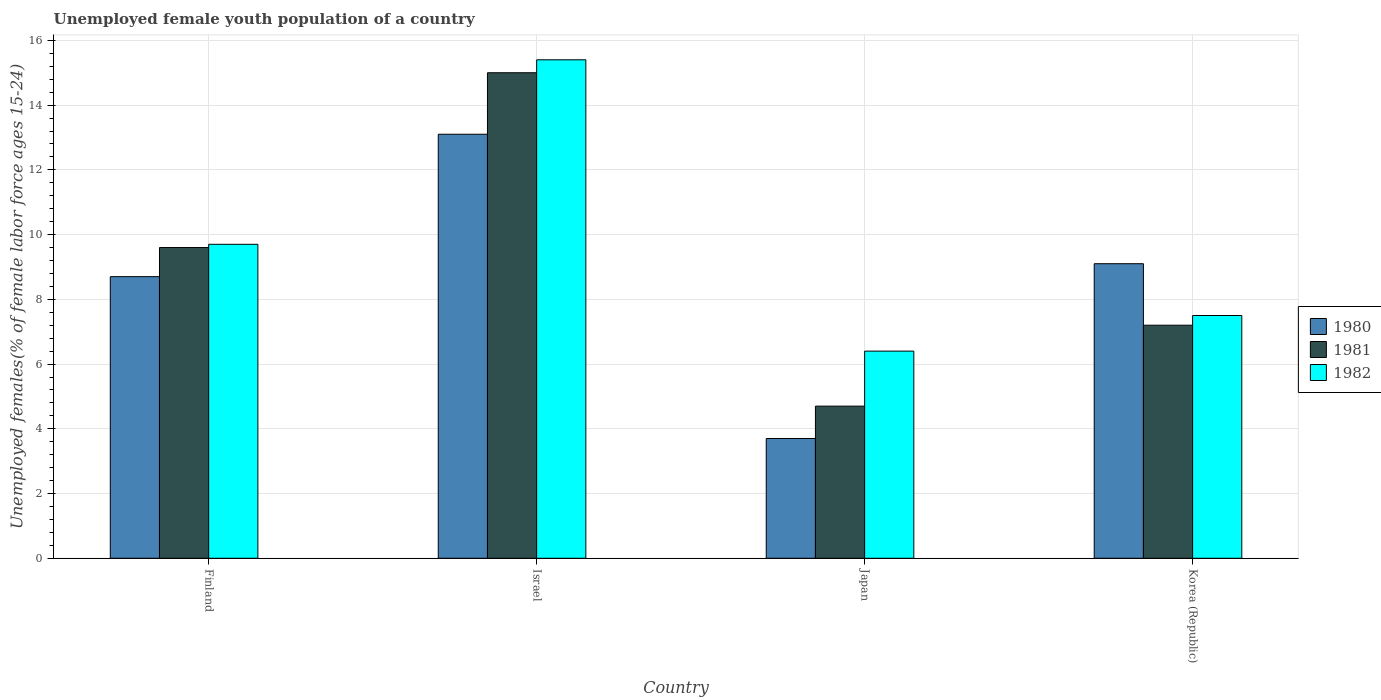How many groups of bars are there?
Keep it short and to the point. 4. Are the number of bars per tick equal to the number of legend labels?
Make the answer very short. Yes. How many bars are there on the 1st tick from the right?
Offer a terse response. 3. What is the label of the 2nd group of bars from the left?
Provide a succinct answer. Israel. What is the percentage of unemployed female youth population in 1980 in Korea (Republic)?
Ensure brevity in your answer.  9.1. Across all countries, what is the maximum percentage of unemployed female youth population in 1982?
Provide a short and direct response. 15.4. Across all countries, what is the minimum percentage of unemployed female youth population in 1980?
Your response must be concise. 3.7. What is the total percentage of unemployed female youth population in 1980 in the graph?
Offer a terse response. 34.6. What is the difference between the percentage of unemployed female youth population in 1981 in Israel and that in Korea (Republic)?
Keep it short and to the point. 7.8. What is the difference between the percentage of unemployed female youth population in 1982 in Korea (Republic) and the percentage of unemployed female youth population in 1980 in Israel?
Provide a succinct answer. -5.6. What is the average percentage of unemployed female youth population in 1980 per country?
Provide a succinct answer. 8.65. What is the difference between the percentage of unemployed female youth population of/in 1980 and percentage of unemployed female youth population of/in 1981 in Japan?
Make the answer very short. -1. In how many countries, is the percentage of unemployed female youth population in 1980 greater than 8.4 %?
Your answer should be compact. 3. What is the ratio of the percentage of unemployed female youth population in 1980 in Israel to that in Korea (Republic)?
Give a very brief answer. 1.44. Is the percentage of unemployed female youth population in 1981 in Finland less than that in Korea (Republic)?
Make the answer very short. No. What is the difference between the highest and the second highest percentage of unemployed female youth population in 1981?
Your response must be concise. 2.4. What is the difference between the highest and the lowest percentage of unemployed female youth population in 1981?
Give a very brief answer. 10.3. Is the sum of the percentage of unemployed female youth population in 1982 in Finland and Israel greater than the maximum percentage of unemployed female youth population in 1980 across all countries?
Offer a very short reply. Yes. What does the 2nd bar from the left in Korea (Republic) represents?
Provide a short and direct response. 1981. What does the 3rd bar from the right in Finland represents?
Offer a terse response. 1980. How many countries are there in the graph?
Give a very brief answer. 4. Does the graph contain grids?
Your response must be concise. Yes. How many legend labels are there?
Keep it short and to the point. 3. How are the legend labels stacked?
Your answer should be very brief. Vertical. What is the title of the graph?
Give a very brief answer. Unemployed female youth population of a country. What is the label or title of the X-axis?
Give a very brief answer. Country. What is the label or title of the Y-axis?
Provide a succinct answer. Unemployed females(% of female labor force ages 15-24). What is the Unemployed females(% of female labor force ages 15-24) in 1980 in Finland?
Your answer should be compact. 8.7. What is the Unemployed females(% of female labor force ages 15-24) in 1981 in Finland?
Keep it short and to the point. 9.6. What is the Unemployed females(% of female labor force ages 15-24) in 1982 in Finland?
Your response must be concise. 9.7. What is the Unemployed females(% of female labor force ages 15-24) of 1980 in Israel?
Keep it short and to the point. 13.1. What is the Unemployed females(% of female labor force ages 15-24) in 1982 in Israel?
Give a very brief answer. 15.4. What is the Unemployed females(% of female labor force ages 15-24) in 1980 in Japan?
Your answer should be compact. 3.7. What is the Unemployed females(% of female labor force ages 15-24) in 1981 in Japan?
Your response must be concise. 4.7. What is the Unemployed females(% of female labor force ages 15-24) in 1982 in Japan?
Your answer should be compact. 6.4. What is the Unemployed females(% of female labor force ages 15-24) in 1980 in Korea (Republic)?
Offer a very short reply. 9.1. What is the Unemployed females(% of female labor force ages 15-24) in 1981 in Korea (Republic)?
Make the answer very short. 7.2. What is the Unemployed females(% of female labor force ages 15-24) in 1982 in Korea (Republic)?
Ensure brevity in your answer.  7.5. Across all countries, what is the maximum Unemployed females(% of female labor force ages 15-24) in 1980?
Make the answer very short. 13.1. Across all countries, what is the maximum Unemployed females(% of female labor force ages 15-24) of 1981?
Your answer should be compact. 15. Across all countries, what is the maximum Unemployed females(% of female labor force ages 15-24) of 1982?
Your answer should be very brief. 15.4. Across all countries, what is the minimum Unemployed females(% of female labor force ages 15-24) of 1980?
Offer a terse response. 3.7. Across all countries, what is the minimum Unemployed females(% of female labor force ages 15-24) of 1981?
Give a very brief answer. 4.7. Across all countries, what is the minimum Unemployed females(% of female labor force ages 15-24) in 1982?
Keep it short and to the point. 6.4. What is the total Unemployed females(% of female labor force ages 15-24) in 1980 in the graph?
Provide a short and direct response. 34.6. What is the total Unemployed females(% of female labor force ages 15-24) in 1981 in the graph?
Your answer should be compact. 36.5. What is the difference between the Unemployed females(% of female labor force ages 15-24) in 1980 in Finland and that in Israel?
Your answer should be very brief. -4.4. What is the difference between the Unemployed females(% of female labor force ages 15-24) in 1982 in Finland and that in Israel?
Your answer should be compact. -5.7. What is the difference between the Unemployed females(% of female labor force ages 15-24) in 1982 in Finland and that in Japan?
Give a very brief answer. 3.3. What is the difference between the Unemployed females(% of female labor force ages 15-24) of 1981 in Finland and that in Korea (Republic)?
Keep it short and to the point. 2.4. What is the difference between the Unemployed females(% of female labor force ages 15-24) of 1980 in Israel and that in Japan?
Provide a succinct answer. 9.4. What is the difference between the Unemployed females(% of female labor force ages 15-24) in 1982 in Israel and that in Japan?
Offer a very short reply. 9. What is the difference between the Unemployed females(% of female labor force ages 15-24) in 1981 in Israel and that in Korea (Republic)?
Provide a succinct answer. 7.8. What is the difference between the Unemployed females(% of female labor force ages 15-24) in 1981 in Japan and that in Korea (Republic)?
Offer a terse response. -2.5. What is the difference between the Unemployed females(% of female labor force ages 15-24) in 1980 in Finland and the Unemployed females(% of female labor force ages 15-24) in 1981 in Israel?
Make the answer very short. -6.3. What is the difference between the Unemployed females(% of female labor force ages 15-24) of 1981 in Finland and the Unemployed females(% of female labor force ages 15-24) of 1982 in Israel?
Make the answer very short. -5.8. What is the difference between the Unemployed females(% of female labor force ages 15-24) of 1980 in Finland and the Unemployed females(% of female labor force ages 15-24) of 1981 in Japan?
Your response must be concise. 4. What is the difference between the Unemployed females(% of female labor force ages 15-24) of 1980 in Finland and the Unemployed females(% of female labor force ages 15-24) of 1982 in Japan?
Offer a terse response. 2.3. What is the difference between the Unemployed females(% of female labor force ages 15-24) of 1980 in Finland and the Unemployed females(% of female labor force ages 15-24) of 1981 in Korea (Republic)?
Make the answer very short. 1.5. What is the difference between the Unemployed females(% of female labor force ages 15-24) in 1980 in Finland and the Unemployed females(% of female labor force ages 15-24) in 1982 in Korea (Republic)?
Your answer should be very brief. 1.2. What is the difference between the Unemployed females(% of female labor force ages 15-24) in 1980 in Israel and the Unemployed females(% of female labor force ages 15-24) in 1981 in Japan?
Your response must be concise. 8.4. What is the difference between the Unemployed females(% of female labor force ages 15-24) in 1980 in Israel and the Unemployed females(% of female labor force ages 15-24) in 1982 in Japan?
Offer a terse response. 6.7. What is the difference between the Unemployed females(% of female labor force ages 15-24) of 1980 in Israel and the Unemployed females(% of female labor force ages 15-24) of 1981 in Korea (Republic)?
Your answer should be compact. 5.9. What is the difference between the Unemployed females(% of female labor force ages 15-24) in 1981 in Israel and the Unemployed females(% of female labor force ages 15-24) in 1982 in Korea (Republic)?
Your response must be concise. 7.5. What is the difference between the Unemployed females(% of female labor force ages 15-24) of 1980 in Japan and the Unemployed females(% of female labor force ages 15-24) of 1981 in Korea (Republic)?
Ensure brevity in your answer.  -3.5. What is the difference between the Unemployed females(% of female labor force ages 15-24) in 1980 in Japan and the Unemployed females(% of female labor force ages 15-24) in 1982 in Korea (Republic)?
Your answer should be very brief. -3.8. What is the average Unemployed females(% of female labor force ages 15-24) of 1980 per country?
Give a very brief answer. 8.65. What is the average Unemployed females(% of female labor force ages 15-24) of 1981 per country?
Ensure brevity in your answer.  9.12. What is the average Unemployed females(% of female labor force ages 15-24) of 1982 per country?
Make the answer very short. 9.75. What is the difference between the Unemployed females(% of female labor force ages 15-24) in 1980 and Unemployed females(% of female labor force ages 15-24) in 1981 in Finland?
Your answer should be very brief. -0.9. What is the difference between the Unemployed females(% of female labor force ages 15-24) of 1980 and Unemployed females(% of female labor force ages 15-24) of 1982 in Finland?
Your answer should be compact. -1. What is the difference between the Unemployed females(% of female labor force ages 15-24) of 1981 and Unemployed females(% of female labor force ages 15-24) of 1982 in Finland?
Provide a succinct answer. -0.1. What is the difference between the Unemployed females(% of female labor force ages 15-24) in 1980 and Unemployed females(% of female labor force ages 15-24) in 1982 in Israel?
Provide a succinct answer. -2.3. What is the difference between the Unemployed females(% of female labor force ages 15-24) in 1980 and Unemployed females(% of female labor force ages 15-24) in 1981 in Japan?
Ensure brevity in your answer.  -1. What is the difference between the Unemployed females(% of female labor force ages 15-24) in 1980 and Unemployed females(% of female labor force ages 15-24) in 1982 in Japan?
Provide a short and direct response. -2.7. What is the difference between the Unemployed females(% of female labor force ages 15-24) of 1981 and Unemployed females(% of female labor force ages 15-24) of 1982 in Japan?
Your answer should be compact. -1.7. What is the difference between the Unemployed females(% of female labor force ages 15-24) in 1980 and Unemployed females(% of female labor force ages 15-24) in 1982 in Korea (Republic)?
Provide a short and direct response. 1.6. What is the ratio of the Unemployed females(% of female labor force ages 15-24) of 1980 in Finland to that in Israel?
Make the answer very short. 0.66. What is the ratio of the Unemployed females(% of female labor force ages 15-24) of 1981 in Finland to that in Israel?
Give a very brief answer. 0.64. What is the ratio of the Unemployed females(% of female labor force ages 15-24) in 1982 in Finland to that in Israel?
Your response must be concise. 0.63. What is the ratio of the Unemployed females(% of female labor force ages 15-24) in 1980 in Finland to that in Japan?
Your answer should be compact. 2.35. What is the ratio of the Unemployed females(% of female labor force ages 15-24) of 1981 in Finland to that in Japan?
Your answer should be compact. 2.04. What is the ratio of the Unemployed females(% of female labor force ages 15-24) in 1982 in Finland to that in Japan?
Make the answer very short. 1.52. What is the ratio of the Unemployed females(% of female labor force ages 15-24) in 1980 in Finland to that in Korea (Republic)?
Provide a short and direct response. 0.96. What is the ratio of the Unemployed females(% of female labor force ages 15-24) in 1981 in Finland to that in Korea (Republic)?
Make the answer very short. 1.33. What is the ratio of the Unemployed females(% of female labor force ages 15-24) in 1982 in Finland to that in Korea (Republic)?
Your answer should be very brief. 1.29. What is the ratio of the Unemployed females(% of female labor force ages 15-24) in 1980 in Israel to that in Japan?
Provide a succinct answer. 3.54. What is the ratio of the Unemployed females(% of female labor force ages 15-24) in 1981 in Israel to that in Japan?
Provide a short and direct response. 3.19. What is the ratio of the Unemployed females(% of female labor force ages 15-24) in 1982 in Israel to that in Japan?
Your response must be concise. 2.41. What is the ratio of the Unemployed females(% of female labor force ages 15-24) of 1980 in Israel to that in Korea (Republic)?
Ensure brevity in your answer.  1.44. What is the ratio of the Unemployed females(% of female labor force ages 15-24) in 1981 in Israel to that in Korea (Republic)?
Provide a short and direct response. 2.08. What is the ratio of the Unemployed females(% of female labor force ages 15-24) of 1982 in Israel to that in Korea (Republic)?
Your answer should be very brief. 2.05. What is the ratio of the Unemployed females(% of female labor force ages 15-24) in 1980 in Japan to that in Korea (Republic)?
Your answer should be compact. 0.41. What is the ratio of the Unemployed females(% of female labor force ages 15-24) in 1981 in Japan to that in Korea (Republic)?
Provide a succinct answer. 0.65. What is the ratio of the Unemployed females(% of female labor force ages 15-24) of 1982 in Japan to that in Korea (Republic)?
Provide a succinct answer. 0.85. What is the difference between the highest and the second highest Unemployed females(% of female labor force ages 15-24) of 1982?
Provide a succinct answer. 5.7. What is the difference between the highest and the lowest Unemployed females(% of female labor force ages 15-24) in 1982?
Give a very brief answer. 9. 